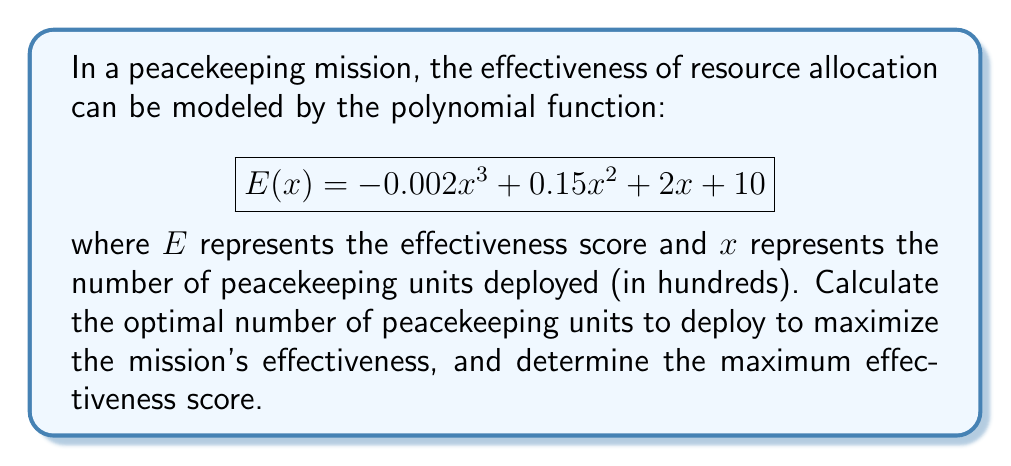Can you solve this math problem? To find the optimal number of peacekeeping units and the maximum effectiveness score, we need to follow these steps:

1. Find the derivative of the effectiveness function:
   $$E'(x) = -0.006x^2 + 0.3x + 2$$

2. Set the derivative equal to zero to find critical points:
   $$-0.006x^2 + 0.3x + 2 = 0$$

3. Solve the quadratic equation:
   $$x = \frac{-0.3 \pm \sqrt{0.3^2 - 4(-0.006)(2)}}{2(-0.006)}$$
   $$x \approx 28.87 \text{ or } -11.54$$

4. Since we're dealing with the number of peacekeeping units, we discard the negative solution. The optimal number of units is approximately 28.87 hundred, or 2,887 units.

5. To verify this is a maximum, check the second derivative:
   $$E''(x) = -0.012x + 0.3$$
   At $x = 28.87$, $E''(28.87) = -0.04644 < 0$, confirming a maximum.

6. Calculate the maximum effectiveness score by plugging the optimal $x$ value into the original function:
   $$E(28.87) = -0.002(28.87)^3 + 0.15(28.87)^2 + 2(28.87) + 10$$
   $$\approx 71.56$$

Therefore, the optimal number of peacekeeping units to deploy is 2,887, which will result in a maximum effectiveness score of approximately 71.56.
Answer: Optimal number of peacekeeping units: 2,887
Maximum effectiveness score: 71.56 